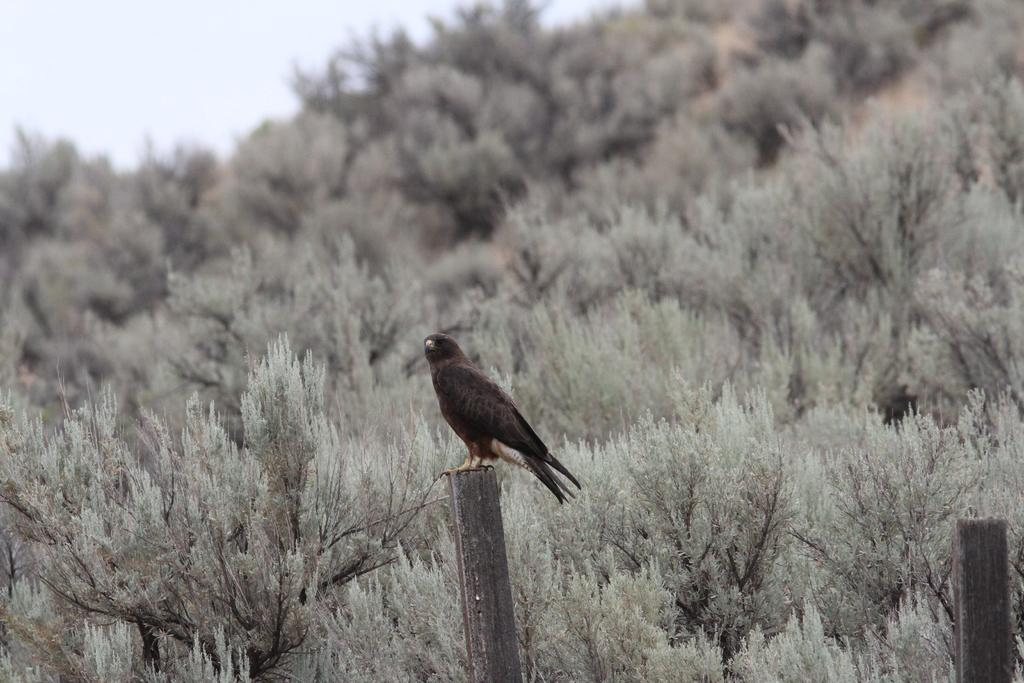What is the main subject of the image? There is a bird standing on a wooden pole in the image. What can be seen in the background of the image? There are trees with branches and leaves in the image. Are there any other wooden poles visible in the image? Yes, there is another wooden pole on the right side of the image. What type of hair can be seen on the bird in the image? There is no hair visible on the bird in the image, as birds do not have hair. What disease is the bird suffering from in the image? There is no indication of any disease in the image, and we cannot diagnose a bird's health from a single image. 